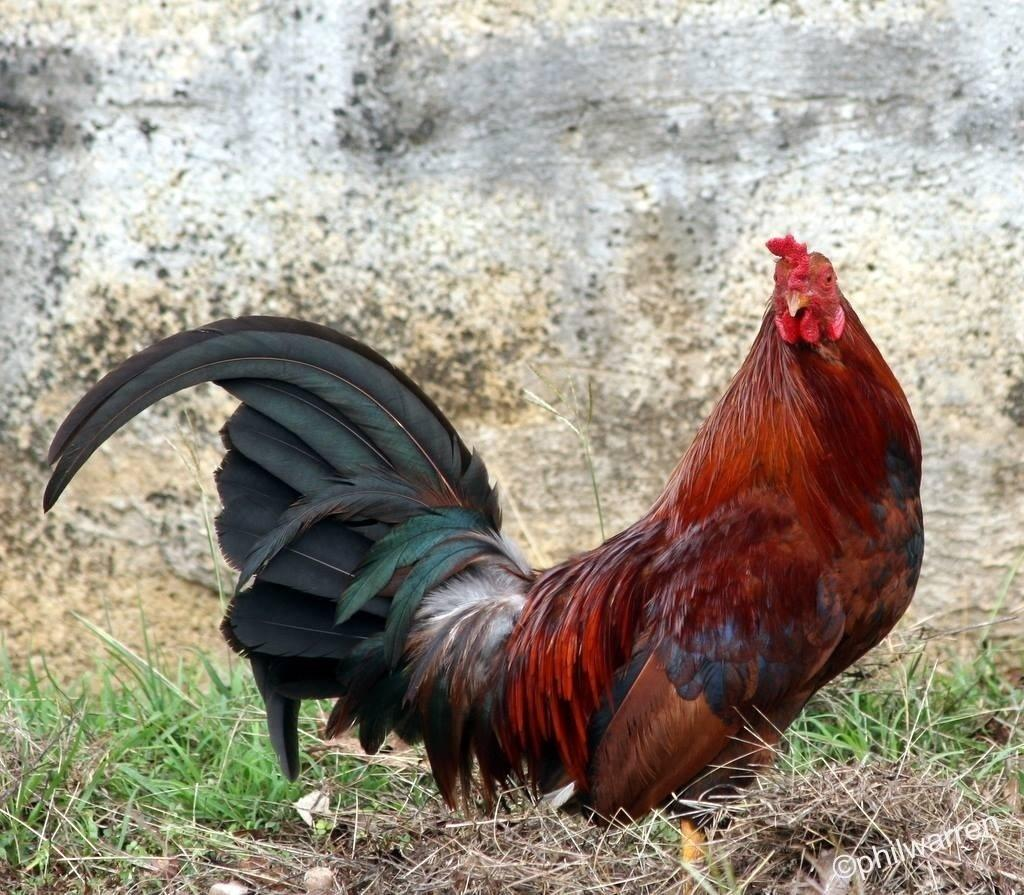What animal can be seen on the ground in the image? There is a hen on the ground in the image. What type of vegetation is visible in the background of the image? There is grass visible in the background of the image. What type of structure can be seen in the background of the image? There is a wall in the background of the image. Where is the text located in the image? The text is in the bottom right corner of the image. How many toes does the hen have in the image? The image does not show the hen's toes, so it is not possible to determine the number of toes. What type of exchange is taking place in the image? There is no exchange taking place in the image; it simply shows a hen on the ground. 